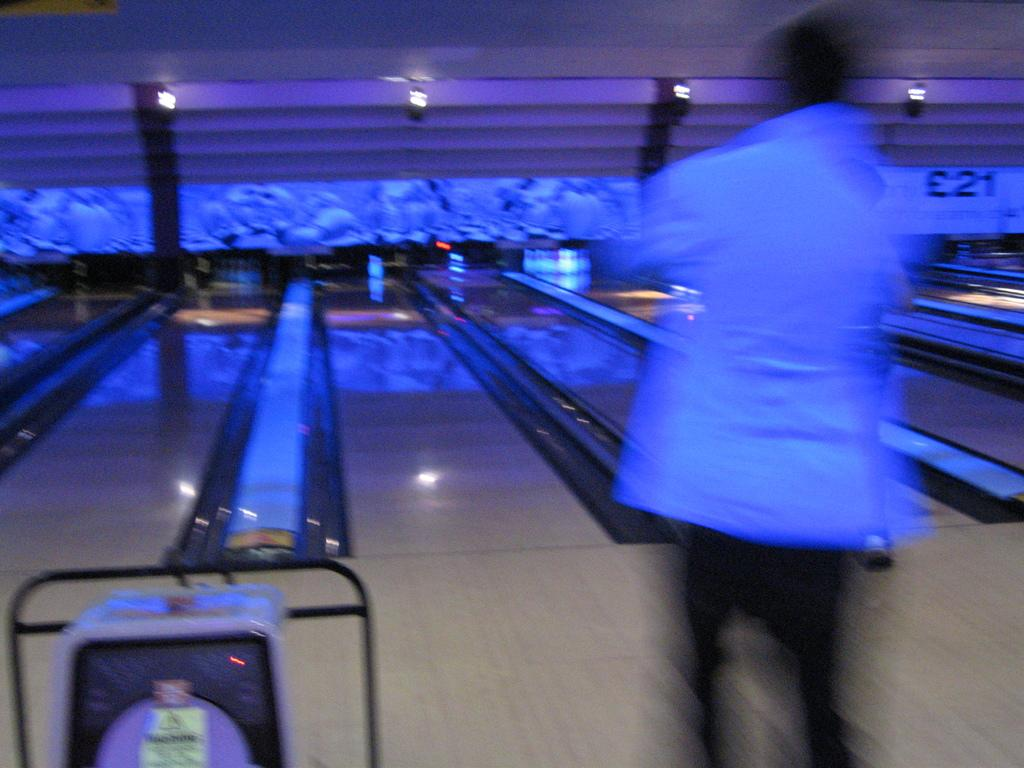What activity is the person in the image engaged in? The person is playing a bowling pin game in the image. What objects are related to the game in the image? There are pins in the background of the image. What can be seen at the top of the image? There are lights at the top of the image. How does the person pull the tank in the image? There is no tank present in the image; the person is playing a bowling pin game. 